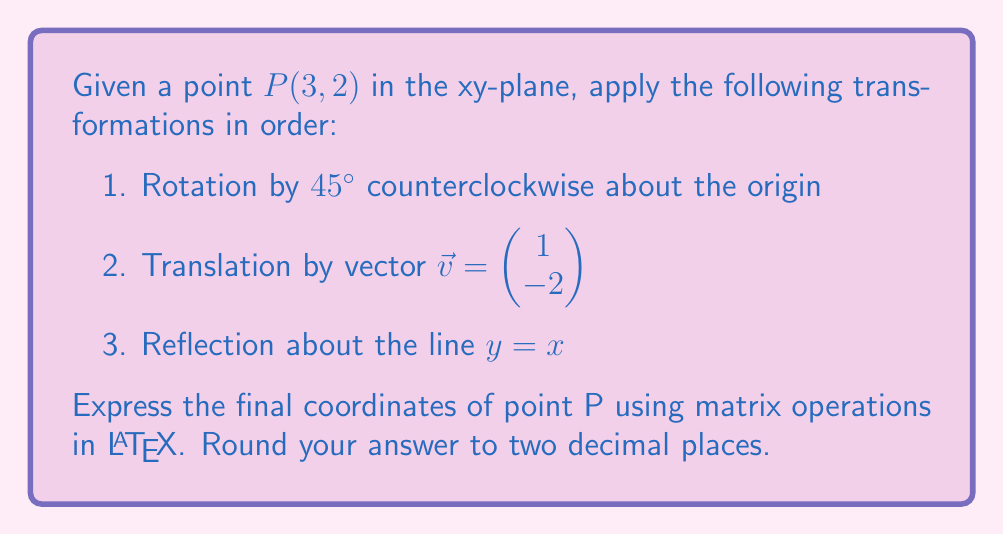Provide a solution to this math problem. Let's break down this problem step-by-step using matrix operations:

1. Rotation by 45° counterclockwise:
   The rotation matrix for a counterclockwise rotation by $\theta$ is:
   $$R_\theta = \begin{pmatrix} \cos\theta & -\sin\theta \\ \sin\theta & \cos\theta \end{pmatrix}$$
   
   For 45°, $\cos 45° = \sin 45° = \frac{1}{\sqrt{2}}$, so:
   $$R_{45°} = \begin{pmatrix} \frac{1}{\sqrt{2}} & -\frac{1}{\sqrt{2}} \\ \frac{1}{\sqrt{2}} & \frac{1}{\sqrt{2}} \end{pmatrix}$$

   Applying this to P(3, 2):
   $$\begin{pmatrix} \frac{1}{\sqrt{2}} & -\frac{1}{\sqrt{2}} \\ \frac{1}{\sqrt{2}} & \frac{1}{\sqrt{2}} \end{pmatrix} \begin{pmatrix} 3 \\ 2 \end{pmatrix} = \begin{pmatrix} \frac{3-2}{\sqrt{2}} \\ \frac{3+2}{\sqrt{2}} \end{pmatrix} = \begin{pmatrix} \frac{1}{\sqrt{2}} \\ \frac{5}{\sqrt{2}} \end{pmatrix}$$

2. Translation by vector $\vec{v} = \begin{pmatrix} 1 \\ -2 \end{pmatrix}$:
   Add the translation vector to the result from step 1:
   $$\begin{pmatrix} \frac{1}{\sqrt{2}} \\ \frac{5}{\sqrt{2}} \end{pmatrix} + \begin{pmatrix} 1 \\ -2 \end{pmatrix} = \begin{pmatrix} \frac{1}{\sqrt{2}} + 1 \\ \frac{5}{\sqrt{2}} - 2 \end{pmatrix}$$

3. Reflection about the line $y = x$:
   The reflection matrix about $y = x$ is:
   $$R_{y=x} = \begin{pmatrix} 0 & 1 \\ 1 & 0 \end{pmatrix}$$

   Applying this to the result from step 2:
   $$\begin{pmatrix} 0 & 1 \\ 1 & 0 \end{pmatrix} \begin{pmatrix} \frac{1}{\sqrt{2}} + 1 \\ \frac{5}{\sqrt{2}} - 2 \end{pmatrix} = \begin{pmatrix} \frac{5}{\sqrt{2}} - 2 \\ \frac{1}{\sqrt{2}} + 1 \end{pmatrix}$$

Now, we need to simplify and round to two decimal places:
$$\begin{pmatrix} \frac{5}{\sqrt{2}} - 2 \\ \frac{1}{\sqrt{2}} + 1 \end{pmatrix} \approx \begin{pmatrix} 1.54 \\ 1.71 \end{pmatrix}$$
Answer: $$P' \approx \begin{pmatrix} 1.54 \\ 1.71 \end{pmatrix}$$ 